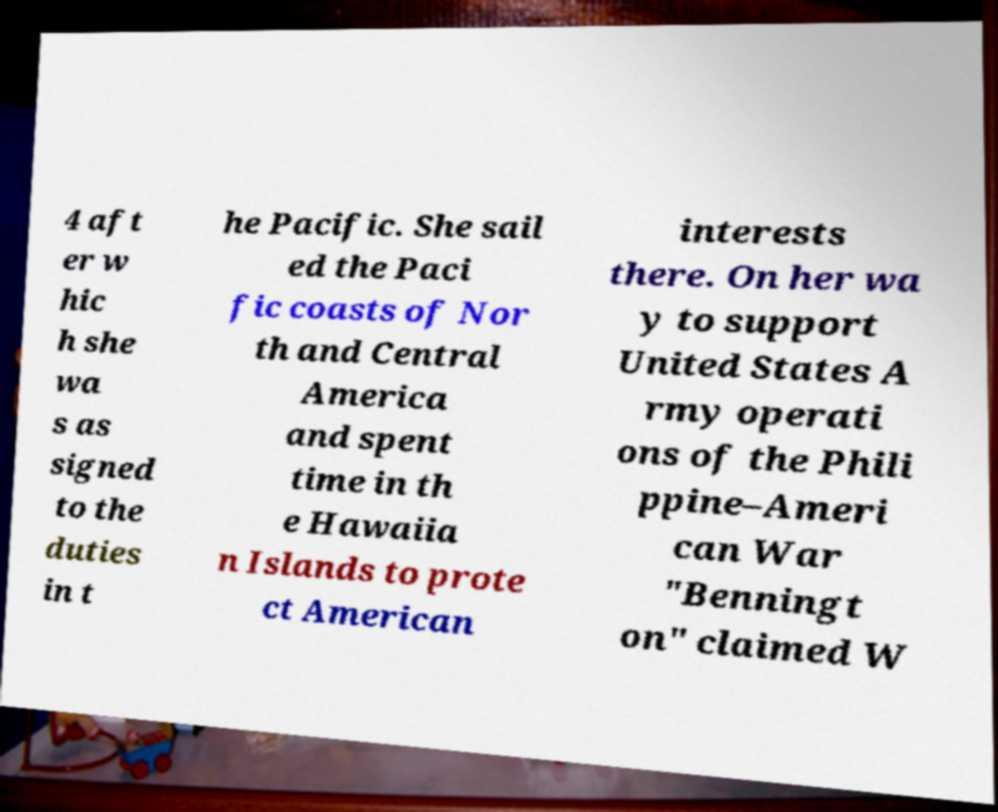There's text embedded in this image that I need extracted. Can you transcribe it verbatim? 4 aft er w hic h she wa s as signed to the duties in t he Pacific. She sail ed the Paci fic coasts of Nor th and Central America and spent time in th e Hawaiia n Islands to prote ct American interests there. On her wa y to support United States A rmy operati ons of the Phili ppine–Ameri can War "Benningt on" claimed W 